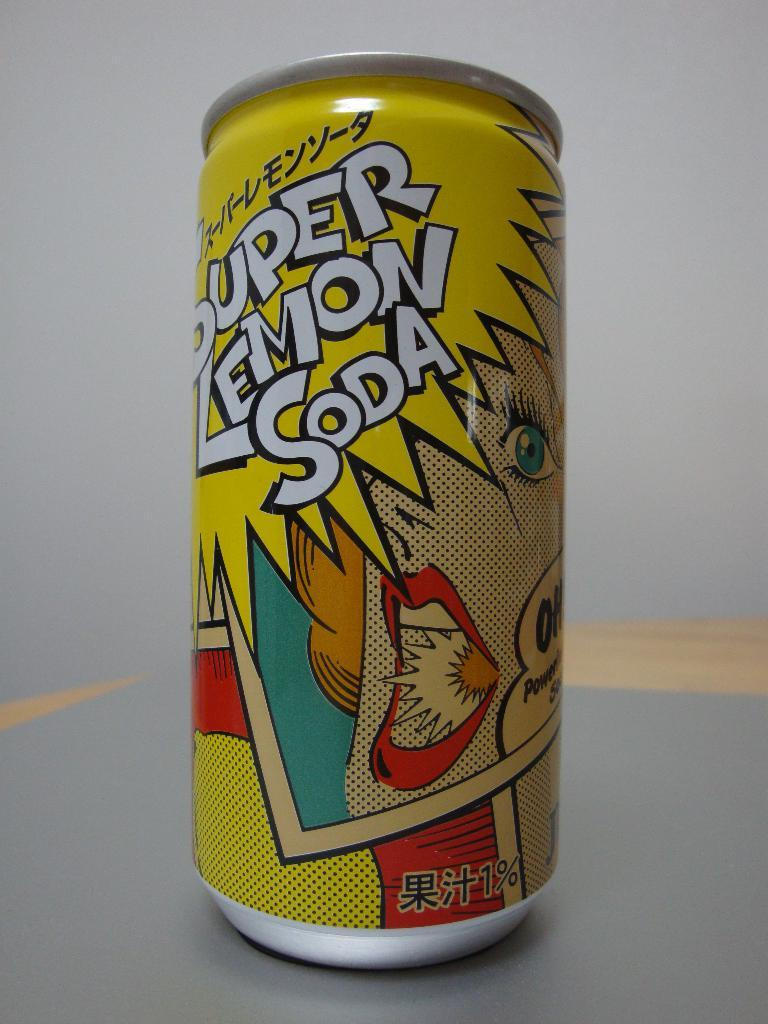<image>
Describe the image concisely. A can of Super Lemon Soda sits on a grey table 